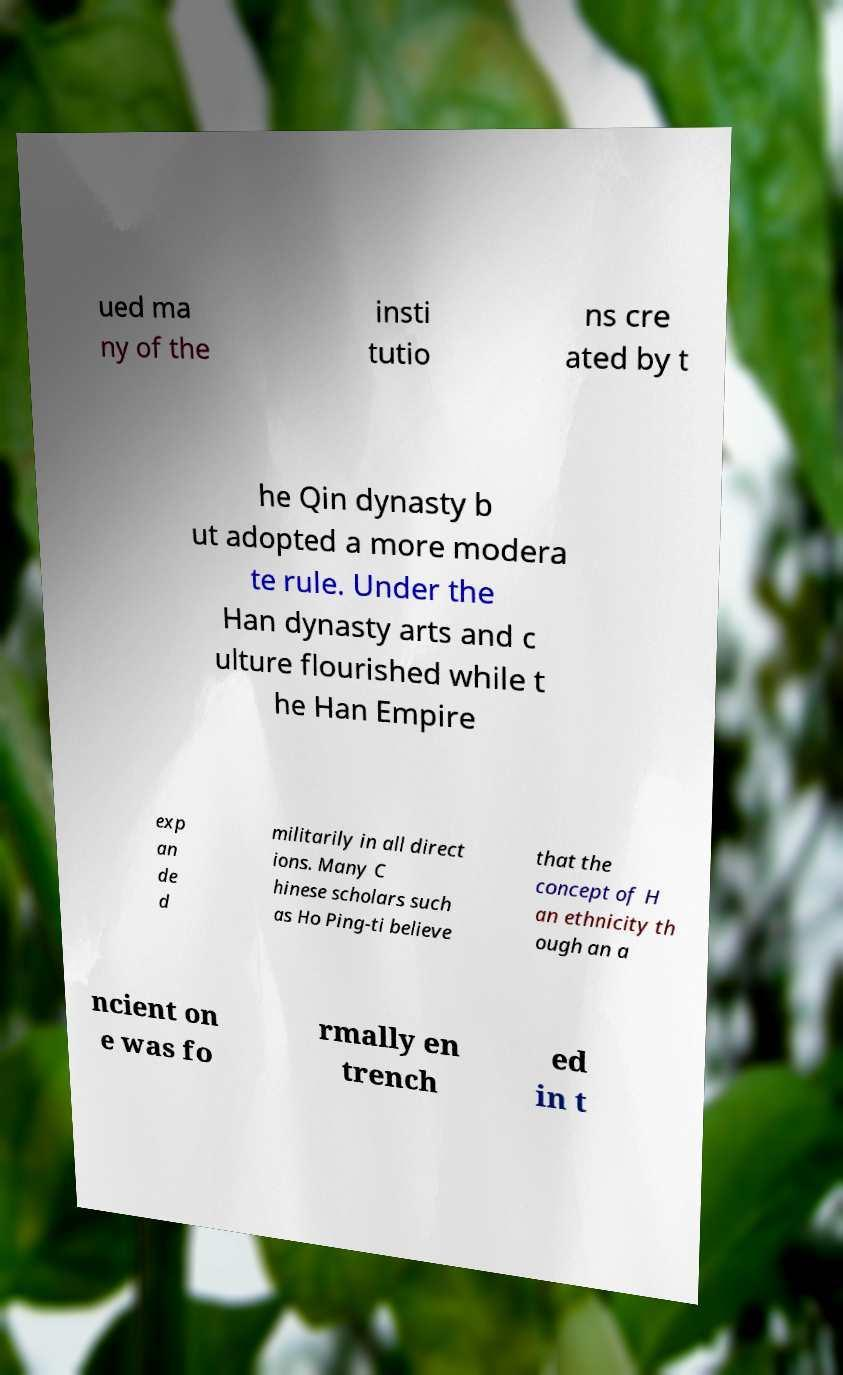Please read and relay the text visible in this image. What does it say? ued ma ny of the insti tutio ns cre ated by t he Qin dynasty b ut adopted a more modera te rule. Under the Han dynasty arts and c ulture flourished while t he Han Empire exp an de d militarily in all direct ions. Many C hinese scholars such as Ho Ping-ti believe that the concept of H an ethnicity th ough an a ncient on e was fo rmally en trench ed in t 